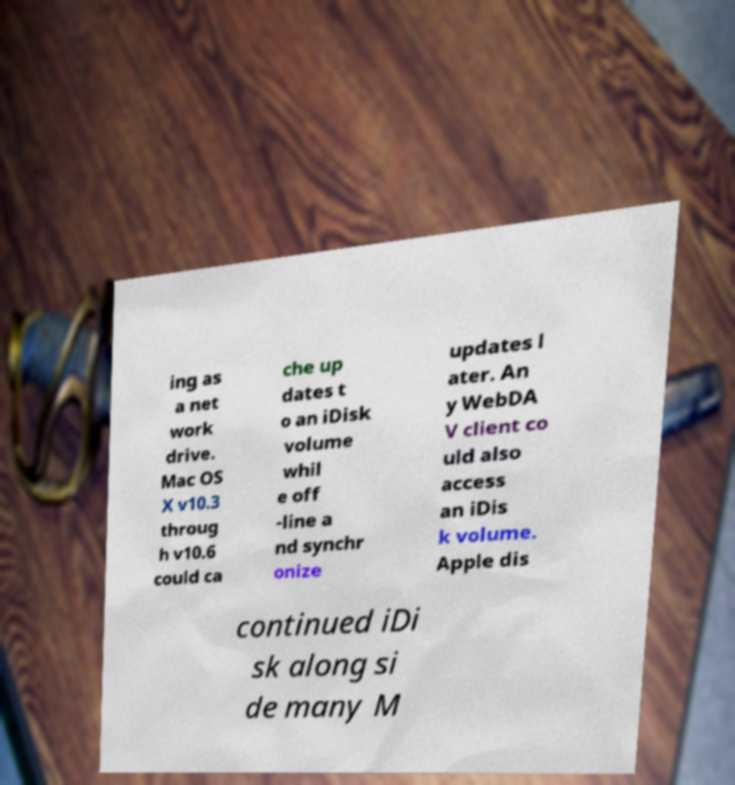Could you extract and type out the text from this image? ing as a net work drive. Mac OS X v10.3 throug h v10.6 could ca che up dates t o an iDisk volume whil e off -line a nd synchr onize updates l ater. An y WebDA V client co uld also access an iDis k volume. Apple dis continued iDi sk along si de many M 